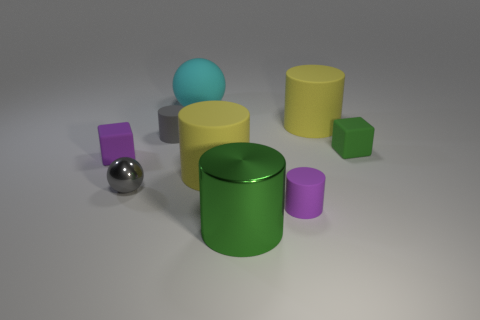There is a thing that is made of the same material as the big green cylinder; what shape is it?
Offer a terse response. Sphere. Are there fewer gray spheres that are on the left side of the small sphere than rubber spheres that are on the right side of the gray cylinder?
Your response must be concise. Yes. What number of big objects are either balls or red matte balls?
Give a very brief answer. 1. Does the purple matte object to the right of the cyan matte object have the same shape as the green object that is left of the tiny purple cylinder?
Make the answer very short. Yes. How big is the purple object on the left side of the small purple matte thing that is right of the big rubber cylinder that is in front of the small gray cylinder?
Keep it short and to the point. Small. What is the size of the cube that is on the right side of the large cyan rubber sphere?
Provide a short and direct response. Small. There is a big thing in front of the gray metallic sphere; what material is it?
Offer a very short reply. Metal. How many gray things are either small metallic objects or tiny metal blocks?
Keep it short and to the point. 1. Is the big cyan ball made of the same material as the tiny purple thing to the right of the large cyan thing?
Offer a very short reply. Yes. Are there an equal number of gray shiny things that are to the left of the tiny gray metal object and matte things in front of the small green block?
Your response must be concise. No. 